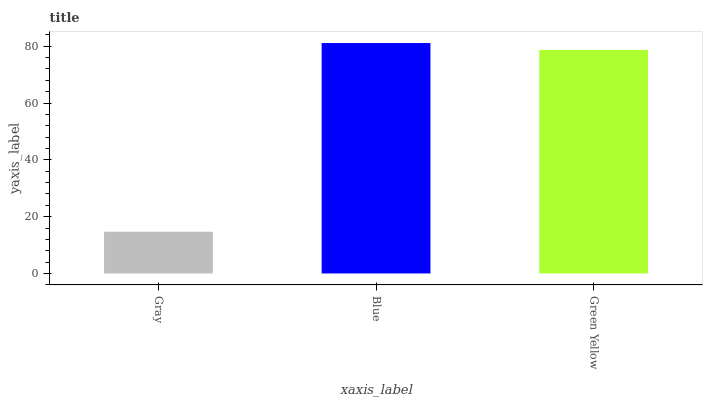Is Gray the minimum?
Answer yes or no. Yes. Is Blue the maximum?
Answer yes or no. Yes. Is Green Yellow the minimum?
Answer yes or no. No. Is Green Yellow the maximum?
Answer yes or no. No. Is Blue greater than Green Yellow?
Answer yes or no. Yes. Is Green Yellow less than Blue?
Answer yes or no. Yes. Is Green Yellow greater than Blue?
Answer yes or no. No. Is Blue less than Green Yellow?
Answer yes or no. No. Is Green Yellow the high median?
Answer yes or no. Yes. Is Green Yellow the low median?
Answer yes or no. Yes. Is Blue the high median?
Answer yes or no. No. Is Gray the low median?
Answer yes or no. No. 